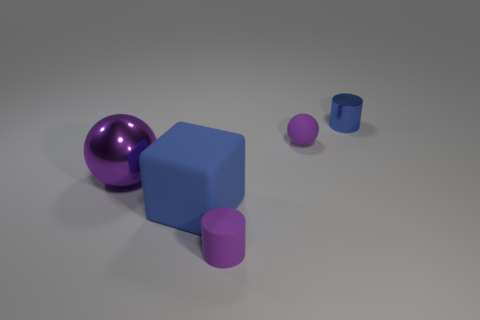Add 3 small yellow blocks. How many objects exist? 8 Subtract all cylinders. How many objects are left? 3 Add 2 big matte blocks. How many big matte blocks exist? 3 Subtract 1 blue cubes. How many objects are left? 4 Subtract all small purple rubber cylinders. Subtract all matte blocks. How many objects are left? 3 Add 3 small blue metallic cylinders. How many small blue metallic cylinders are left? 4 